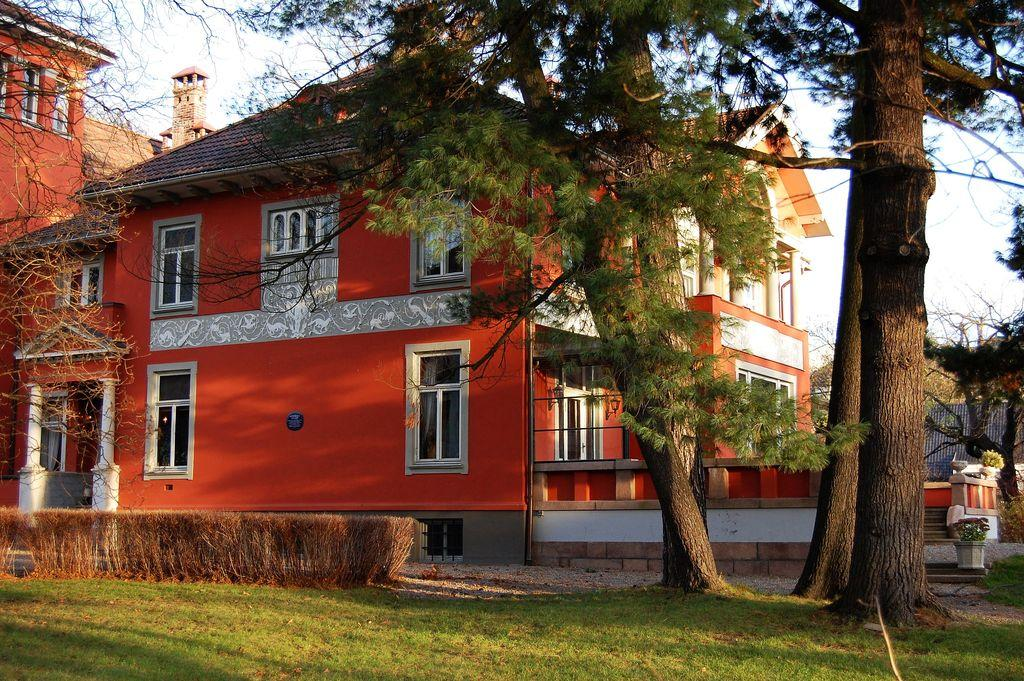What type of structures can be seen in the image? There are buildings in the image. What feature is visible on the buildings? There are windows visible in the image. What type of vegetation is present in the image? There are plants and trees in the image. What part of the natural environment is visible in the image? The sky is visible in the image. Can you tell me how many times the person in the image checked their pocket for a map? There is no person present in the image, and therefore no one to check their pocket for a map. 